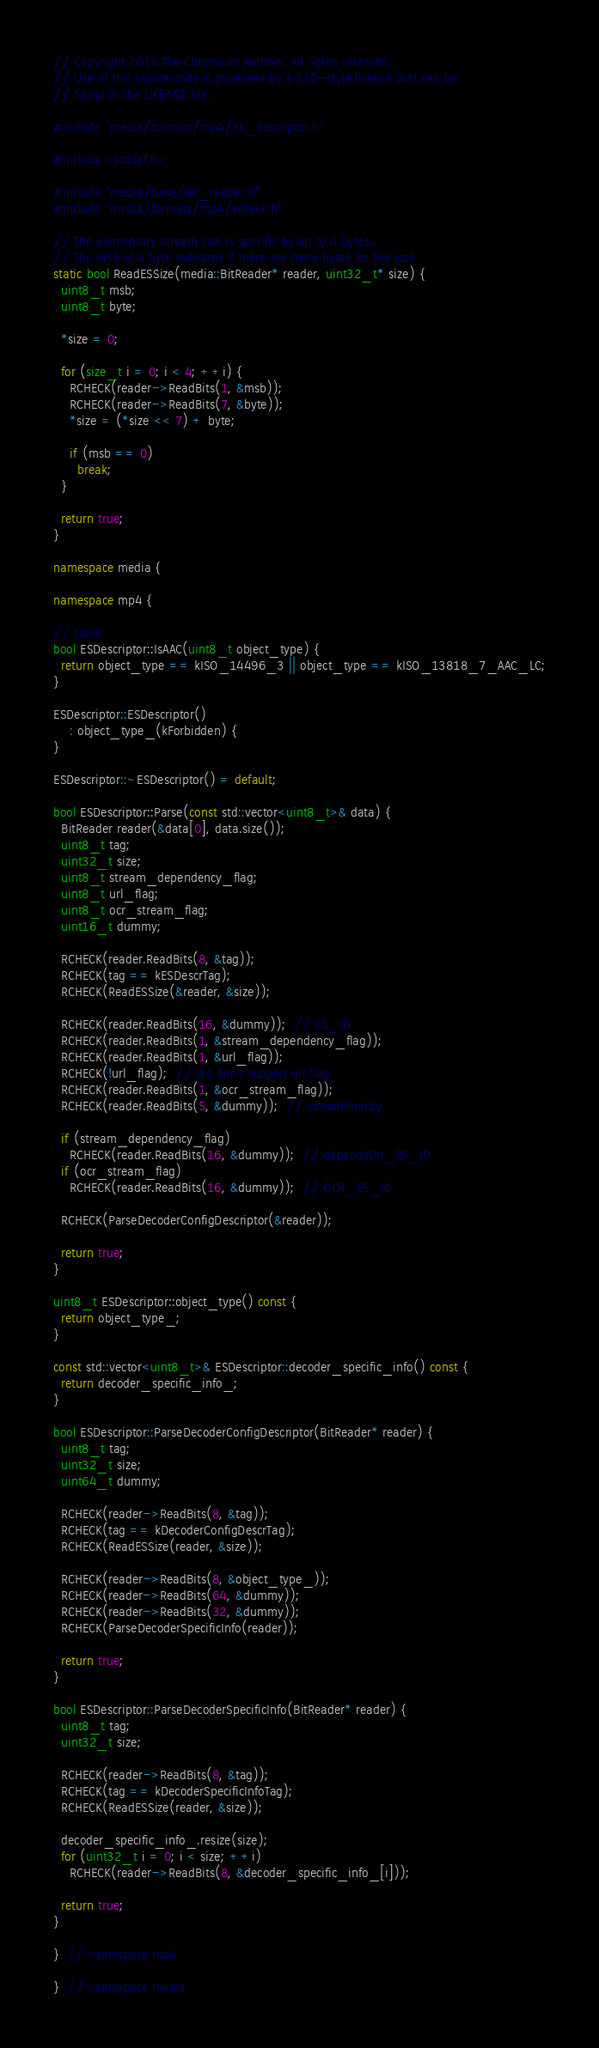<code> <loc_0><loc_0><loc_500><loc_500><_C++_>// Copyright 2014 The Chromium Authors. All rights reserved.
// Use of this source code is governed by a BSD-style license that can be
// found in the LICENSE file.

#include "media/formats/mp4/es_descriptor.h"

#include <stddef.h>

#include "media/base/bit_reader.h"
#include "media/formats/mp4/rcheck.h"

// The elementary stream size is specific by up to 4 bytes.
// The MSB of a byte indicates if there are more bytes for the size.
static bool ReadESSize(media::BitReader* reader, uint32_t* size) {
  uint8_t msb;
  uint8_t byte;

  *size = 0;

  for (size_t i = 0; i < 4; ++i) {
    RCHECK(reader->ReadBits(1, &msb));
    RCHECK(reader->ReadBits(7, &byte));
    *size = (*size << 7) + byte;

    if (msb == 0)
      break;
  }

  return true;
}

namespace media {

namespace mp4 {

// static
bool ESDescriptor::IsAAC(uint8_t object_type) {
  return object_type == kISO_14496_3 || object_type == kISO_13818_7_AAC_LC;
}

ESDescriptor::ESDescriptor()
    : object_type_(kForbidden) {
}

ESDescriptor::~ESDescriptor() = default;

bool ESDescriptor::Parse(const std::vector<uint8_t>& data) {
  BitReader reader(&data[0], data.size());
  uint8_t tag;
  uint32_t size;
  uint8_t stream_dependency_flag;
  uint8_t url_flag;
  uint8_t ocr_stream_flag;
  uint16_t dummy;

  RCHECK(reader.ReadBits(8, &tag));
  RCHECK(tag == kESDescrTag);
  RCHECK(ReadESSize(&reader, &size));

  RCHECK(reader.ReadBits(16, &dummy));  // ES_ID
  RCHECK(reader.ReadBits(1, &stream_dependency_flag));
  RCHECK(reader.ReadBits(1, &url_flag));
  RCHECK(!url_flag);  // We don't support url flag
  RCHECK(reader.ReadBits(1, &ocr_stream_flag));
  RCHECK(reader.ReadBits(5, &dummy));  // streamPriority

  if (stream_dependency_flag)
    RCHECK(reader.ReadBits(16, &dummy));  // dependsOn_ES_ID
  if (ocr_stream_flag)
    RCHECK(reader.ReadBits(16, &dummy));  // OCR_ES_Id

  RCHECK(ParseDecoderConfigDescriptor(&reader));

  return true;
}

uint8_t ESDescriptor::object_type() const {
  return object_type_;
}

const std::vector<uint8_t>& ESDescriptor::decoder_specific_info() const {
  return decoder_specific_info_;
}

bool ESDescriptor::ParseDecoderConfigDescriptor(BitReader* reader) {
  uint8_t tag;
  uint32_t size;
  uint64_t dummy;

  RCHECK(reader->ReadBits(8, &tag));
  RCHECK(tag == kDecoderConfigDescrTag);
  RCHECK(ReadESSize(reader, &size));

  RCHECK(reader->ReadBits(8, &object_type_));
  RCHECK(reader->ReadBits(64, &dummy));
  RCHECK(reader->ReadBits(32, &dummy));
  RCHECK(ParseDecoderSpecificInfo(reader));

  return true;
}

bool ESDescriptor::ParseDecoderSpecificInfo(BitReader* reader) {
  uint8_t tag;
  uint32_t size;

  RCHECK(reader->ReadBits(8, &tag));
  RCHECK(tag == kDecoderSpecificInfoTag);
  RCHECK(ReadESSize(reader, &size));

  decoder_specific_info_.resize(size);
  for (uint32_t i = 0; i < size; ++i)
    RCHECK(reader->ReadBits(8, &decoder_specific_info_[i]));

  return true;
}

}  // namespace mp4

}  // namespace media
</code> 